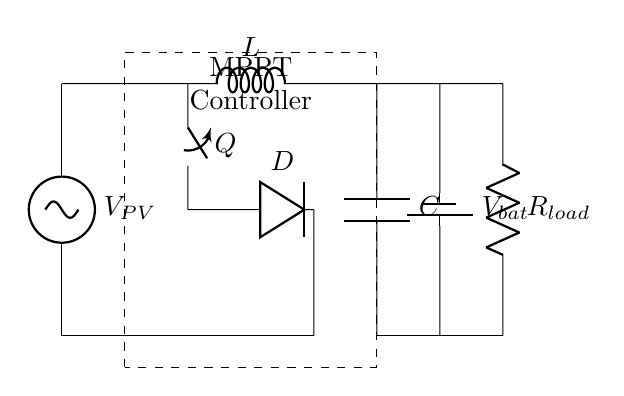What is the type of power source used in the circuit? The circuit uses a solar panel as its power source, indicated by the labeled voltage source $V_{PV}$.
Answer: solar panel What component is responsible for controlling the maximum power output? The dashed rectangle labeled "MPPT Controller" indicates that this component is responsible for managing the maximum power point tracking, optimizing the output from the solar panel.
Answer: MPPT Controller How many major components are represented in this circuit? The major components include the solar panel, MPPT controller, buck converter, capacitor, battery, and load resistance, totaling six distinct components.
Answer: six What is the role of the inductor in the buck converter? The inductor labeled $L$ in the circuit stores energy when the switch $Q$ is closed and releases it when the switch opens, which helps to regulate the output voltage to the battery effectively.
Answer: energy storage What happens if the switch $Q$ is opened during operation? When switch $Q$ is opened, the flow of current from the solar panel stops, causing the stored energy in the inductor to be released through the diode $D$ and charging the output capacitor until the load draws power.
Answer: stops current flow What is the purpose of the capacitor marked $C$? The capacitor $C$ smooths the output voltage by storing charge and releasing it as needed, ensuring a stable voltage supply to the battery and load.
Answer: voltage smoothing 